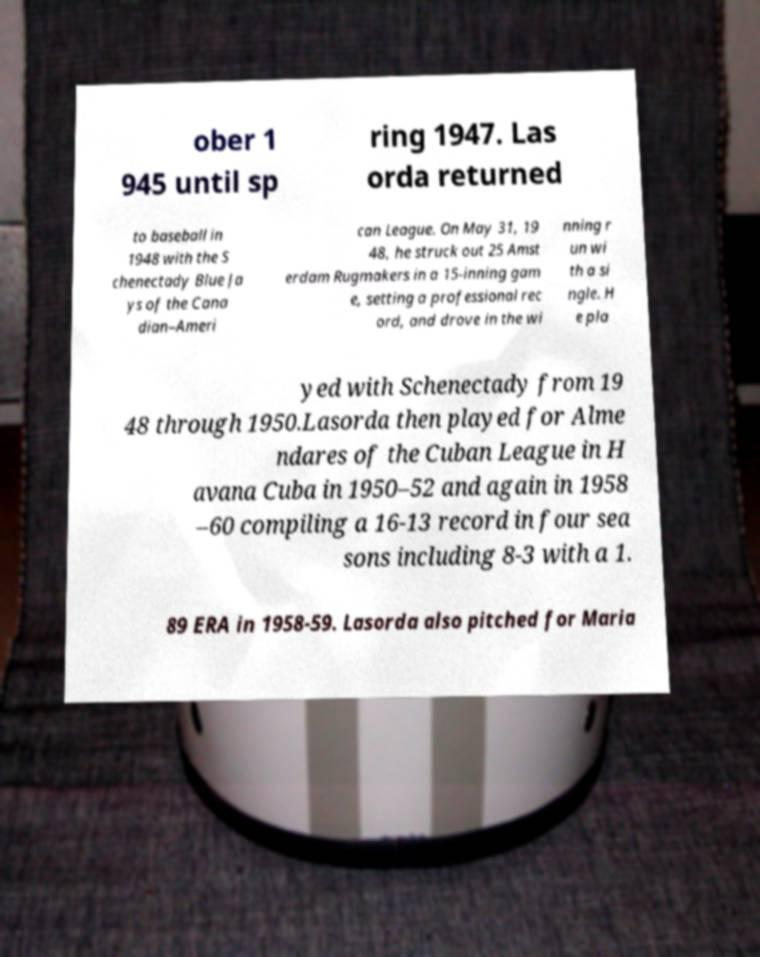Could you assist in decoding the text presented in this image and type it out clearly? ober 1 945 until sp ring 1947. Las orda returned to baseball in 1948 with the S chenectady Blue Ja ys of the Cana dian–Ameri can League. On May 31, 19 48, he struck out 25 Amst erdam Rugmakers in a 15-inning gam e, setting a professional rec ord, and drove in the wi nning r un wi th a si ngle. H e pla yed with Schenectady from 19 48 through 1950.Lasorda then played for Alme ndares of the Cuban League in H avana Cuba in 1950–52 and again in 1958 –60 compiling a 16-13 record in four sea sons including 8-3 with a 1. 89 ERA in 1958-59. Lasorda also pitched for Maria 